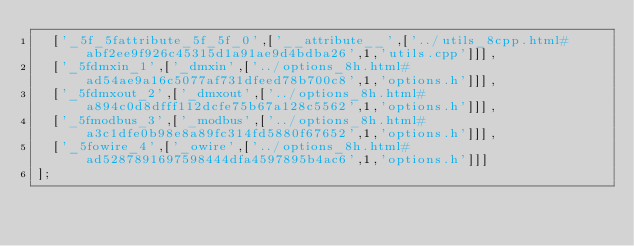<code> <loc_0><loc_0><loc_500><loc_500><_JavaScript_>  ['_5f_5fattribute_5f_5f_0',['__attribute__',['../utils_8cpp.html#abf2ee9f926c45315d1a91ae9d4bdba26',1,'utils.cpp']]],
  ['_5fdmxin_1',['_dmxin',['../options_8h.html#ad54ae9a16c5077af731dfeed78b700c8',1,'options.h']]],
  ['_5fdmxout_2',['_dmxout',['../options_8h.html#a894c0d8dfff112dcfe75b67a128c5562',1,'options.h']]],
  ['_5fmodbus_3',['_modbus',['../options_8h.html#a3c1dfe0b98e8a89fc314fd5880f67652',1,'options.h']]],
  ['_5fowire_4',['_owire',['../options_8h.html#ad5287891697598444dfa4597895b4ac6',1,'options.h']]]
];
</code> 